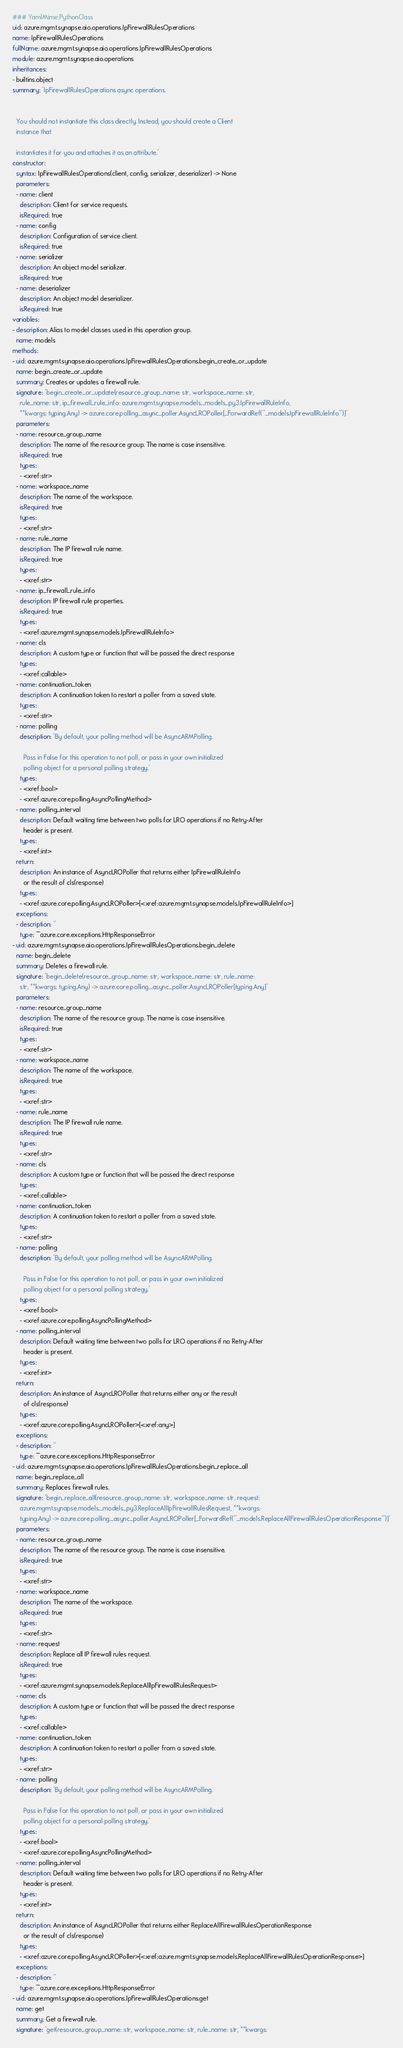Convert code to text. <code><loc_0><loc_0><loc_500><loc_500><_YAML_>### YamlMime:PythonClass
uid: azure.mgmt.synapse.aio.operations.IpFirewallRulesOperations
name: IpFirewallRulesOperations
fullName: azure.mgmt.synapse.aio.operations.IpFirewallRulesOperations
module: azure.mgmt.synapse.aio.operations
inheritances:
- builtins.object
summary: 'IpFirewallRulesOperations async operations.


  You should not instantiate this class directly. Instead, you should create a Client
  instance that

  instantiates it for you and attaches it as an attribute.'
constructor:
  syntax: IpFirewallRulesOperations(client, config, serializer, deserializer) -> None
  parameters:
  - name: client
    description: Client for service requests.
    isRequired: true
  - name: config
    description: Configuration of service client.
    isRequired: true
  - name: serializer
    description: An object model serializer.
    isRequired: true
  - name: deserializer
    description: An object model deserializer.
    isRequired: true
variables:
- description: Alias to model classes used in this operation group.
  name: models
methods:
- uid: azure.mgmt.synapse.aio.operations.IpFirewallRulesOperations.begin_create_or_update
  name: begin_create_or_update
  summary: Creates or updates a firewall rule.
  signature: 'begin_create_or_update(resource_group_name: str, workspace_name: str,
    rule_name: str, ip_firewall_rule_info: azure.mgmt.synapse.models._models_py3.IpFirewallRuleInfo,
    **kwargs: typing.Any) -> azure.core.polling._async_poller.AsyncLROPoller[_ForwardRef(''_models.IpFirewallRuleInfo'')]'
  parameters:
  - name: resource_group_name
    description: The name of the resource group. The name is case insensitive.
    isRequired: true
    types:
    - <xref:str>
  - name: workspace_name
    description: The name of the workspace.
    isRequired: true
    types:
    - <xref:str>
  - name: rule_name
    description: The IP firewall rule name.
    isRequired: true
    types:
    - <xref:str>
  - name: ip_firewall_rule_info
    description: IP firewall rule properties.
    isRequired: true
    types:
    - <xref:azure.mgmt.synapse.models.IpFirewallRuleInfo>
  - name: cls
    description: A custom type or function that will be passed the direct response
    types:
    - <xref:callable>
  - name: continuation_token
    description: A continuation token to restart a poller from a saved state.
    types:
    - <xref:str>
  - name: polling
    description: 'By default, your polling method will be AsyncARMPolling.

      Pass in False for this operation to not poll, or pass in your own initialized
      polling object for a personal polling strategy.'
    types:
    - <xref:bool>
    - <xref:azure.core.polling.AsyncPollingMethod>
  - name: polling_interval
    description: Default waiting time between two polls for LRO operations if no Retry-After
      header is present.
    types:
    - <xref:int>
  return:
    description: An instance of AsyncLROPoller that returns either IpFirewallRuleInfo
      or the result of cls(response)
    types:
    - <xref:azure.core.polling.AsyncLROPoller>[<xref:azure.mgmt.synapse.models.IpFirewallRuleInfo>]
  exceptions:
  - description: ''
    type: ~azure.core.exceptions.HttpResponseError
- uid: azure.mgmt.synapse.aio.operations.IpFirewallRulesOperations.begin_delete
  name: begin_delete
  summary: Deletes a firewall rule.
  signature: 'begin_delete(resource_group_name: str, workspace_name: str, rule_name:
    str, **kwargs: typing.Any) -> azure.core.polling._async_poller.AsyncLROPoller[typing.Any]'
  parameters:
  - name: resource_group_name
    description: The name of the resource group. The name is case insensitive.
    isRequired: true
    types:
    - <xref:str>
  - name: workspace_name
    description: The name of the workspace.
    isRequired: true
    types:
    - <xref:str>
  - name: rule_name
    description: The IP firewall rule name.
    isRequired: true
    types:
    - <xref:str>
  - name: cls
    description: A custom type or function that will be passed the direct response
    types:
    - <xref:callable>
  - name: continuation_token
    description: A continuation token to restart a poller from a saved state.
    types:
    - <xref:str>
  - name: polling
    description: 'By default, your polling method will be AsyncARMPolling.

      Pass in False for this operation to not poll, or pass in your own initialized
      polling object for a personal polling strategy.'
    types:
    - <xref:bool>
    - <xref:azure.core.polling.AsyncPollingMethod>
  - name: polling_interval
    description: Default waiting time between two polls for LRO operations if no Retry-After
      header is present.
    types:
    - <xref:int>
  return:
    description: An instance of AsyncLROPoller that returns either any or the result
      of cls(response)
    types:
    - <xref:azure.core.polling.AsyncLROPoller>[<xref:any>]
  exceptions:
  - description: ''
    type: ~azure.core.exceptions.HttpResponseError
- uid: azure.mgmt.synapse.aio.operations.IpFirewallRulesOperations.begin_replace_all
  name: begin_replace_all
  summary: Replaces firewall rules.
  signature: 'begin_replace_all(resource_group_name: str, workspace_name: str, request:
    azure.mgmt.synapse.models._models_py3.ReplaceAllIpFirewallRulesRequest, **kwargs:
    typing.Any) -> azure.core.polling._async_poller.AsyncLROPoller[_ForwardRef(''_models.ReplaceAllFirewallRulesOperationResponse'')]'
  parameters:
  - name: resource_group_name
    description: The name of the resource group. The name is case insensitive.
    isRequired: true
    types:
    - <xref:str>
  - name: workspace_name
    description: The name of the workspace.
    isRequired: true
    types:
    - <xref:str>
  - name: request
    description: Replace all IP firewall rules request.
    isRequired: true
    types:
    - <xref:azure.mgmt.synapse.models.ReplaceAllIpFirewallRulesRequest>
  - name: cls
    description: A custom type or function that will be passed the direct response
    types:
    - <xref:callable>
  - name: continuation_token
    description: A continuation token to restart a poller from a saved state.
    types:
    - <xref:str>
  - name: polling
    description: 'By default, your polling method will be AsyncARMPolling.

      Pass in False for this operation to not poll, or pass in your own initialized
      polling object for a personal polling strategy.'
    types:
    - <xref:bool>
    - <xref:azure.core.polling.AsyncPollingMethod>
  - name: polling_interval
    description: Default waiting time between two polls for LRO operations if no Retry-After
      header is present.
    types:
    - <xref:int>
  return:
    description: An instance of AsyncLROPoller that returns either ReplaceAllFirewallRulesOperationResponse
      or the result of cls(response)
    types:
    - <xref:azure.core.polling.AsyncLROPoller>[<xref:azure.mgmt.synapse.models.ReplaceAllFirewallRulesOperationResponse>]
  exceptions:
  - description: ''
    type: ~azure.core.exceptions.HttpResponseError
- uid: azure.mgmt.synapse.aio.operations.IpFirewallRulesOperations.get
  name: get
  summary: Get a firewall rule.
  signature: 'get(resource_group_name: str, workspace_name: str, rule_name: str, **kwargs:</code> 